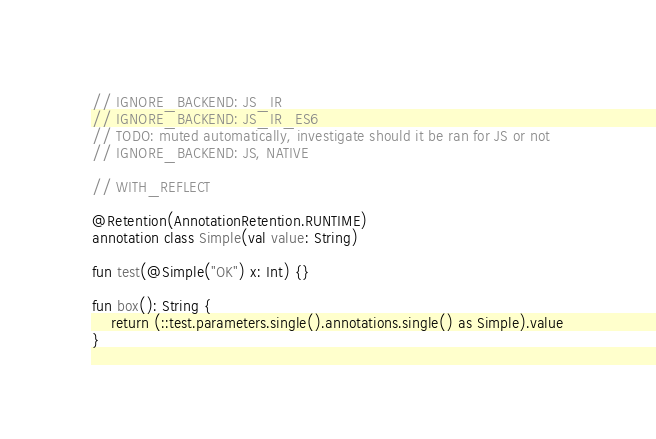<code> <loc_0><loc_0><loc_500><loc_500><_Kotlin_>// IGNORE_BACKEND: JS_IR
// IGNORE_BACKEND: JS_IR_ES6
// TODO: muted automatically, investigate should it be ran for JS or not
// IGNORE_BACKEND: JS, NATIVE

// WITH_REFLECT

@Retention(AnnotationRetention.RUNTIME)
annotation class Simple(val value: String)

fun test(@Simple("OK") x: Int) {}

fun box(): String {
    return (::test.parameters.single().annotations.single() as Simple).value
}
</code> 